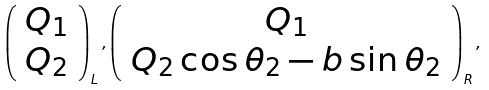Convert formula to latex. <formula><loc_0><loc_0><loc_500><loc_500>\left ( \begin{array} { c } { { Q _ { 1 } } } \\ { { Q _ { 2 } } } \end{array} \right ) _ { L } , \left ( \begin{array} { c } { { Q _ { 1 } } } \\ { { Q _ { 2 } \cos \theta _ { 2 } - b \sin \theta _ { 2 } } } \end{array} \right ) _ { R } ,</formula> 